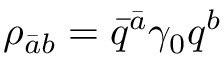Convert formula to latex. <formula><loc_0><loc_0><loc_500><loc_500>\rho _ { \bar { a } b } = \bar { q } ^ { \bar { a } } \gamma _ { 0 } q ^ { b }</formula> 